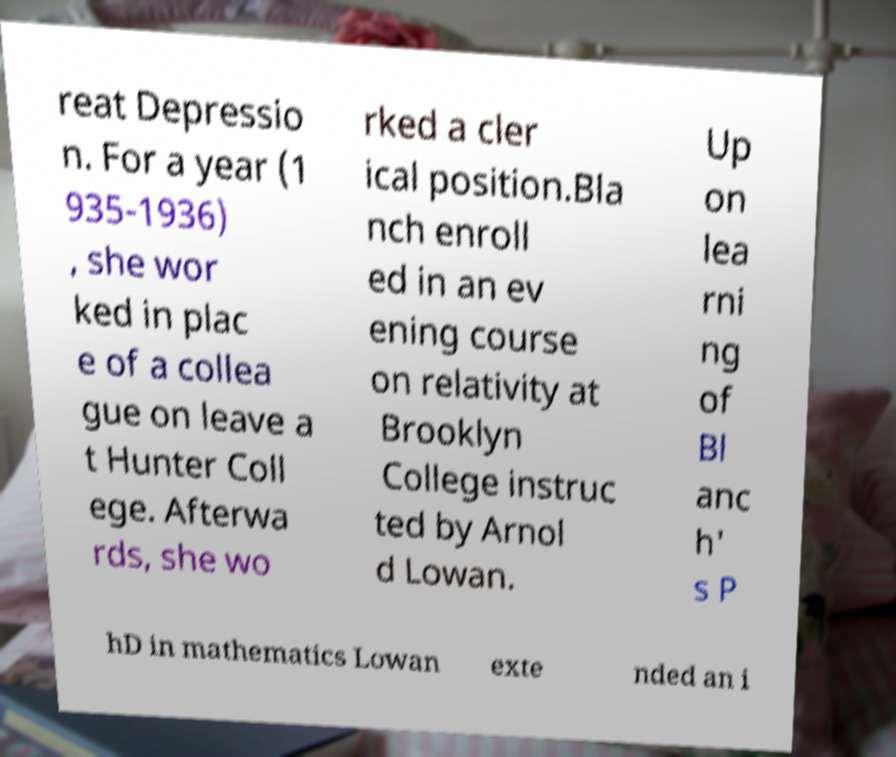Please read and relay the text visible in this image. What does it say? reat Depressio n. For a year (1 935-1936) , she wor ked in plac e of a collea gue on leave a t Hunter Coll ege. Afterwa rds, she wo rked a cler ical position.Bla nch enroll ed in an ev ening course on relativity at Brooklyn College instruc ted by Arnol d Lowan. Up on lea rni ng of Bl anc h' s P hD in mathematics Lowan exte nded an i 